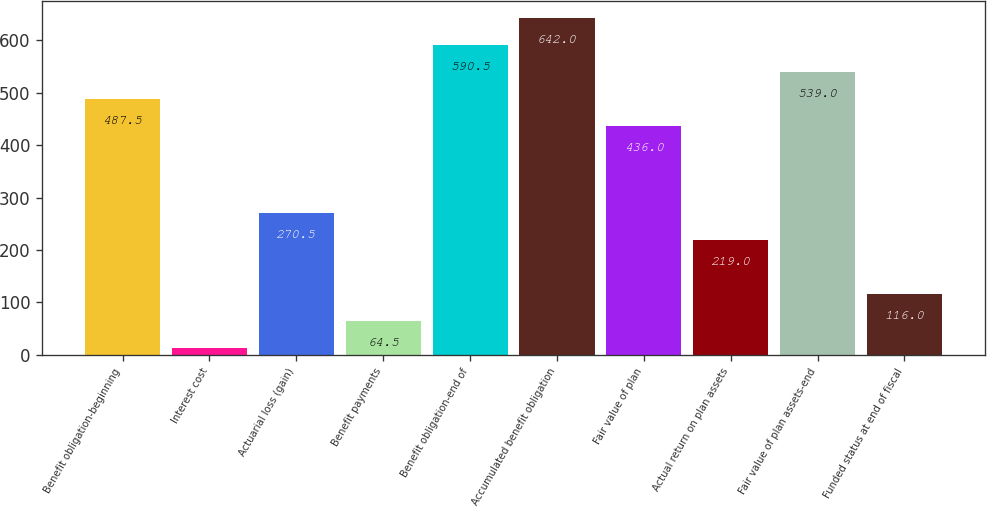Convert chart to OTSL. <chart><loc_0><loc_0><loc_500><loc_500><bar_chart><fcel>Benefit obligation-beginning<fcel>Interest cost<fcel>Actuarial loss (gain)<fcel>Benefit payments<fcel>Benefit obligation-end of<fcel>Accumulated benefit obligation<fcel>Fair value of plan<fcel>Actual return on plan assets<fcel>Fair value of plan assets-end<fcel>Funded status at end of fiscal<nl><fcel>487.5<fcel>13<fcel>270.5<fcel>64.5<fcel>590.5<fcel>642<fcel>436<fcel>219<fcel>539<fcel>116<nl></chart> 